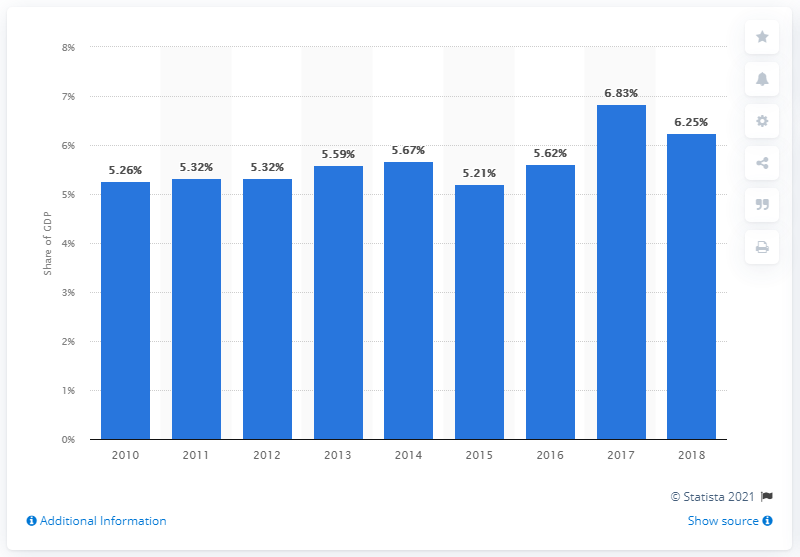Point out several critical features in this image. In 2018, the Bahamas' Gross Domestic Product (GDP) allocated 5.21% of its total expenditure towards healthcare. 